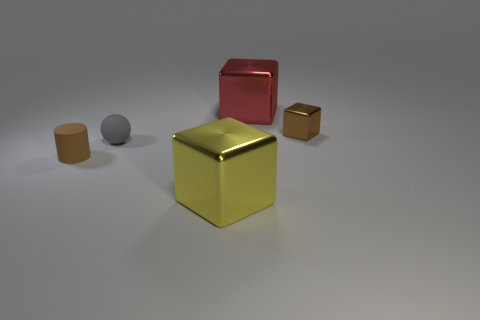What shape is the brown object on the left side of the tiny matte thing that is on the right side of the small cylinder?
Your answer should be compact. Cylinder. What number of other objects are the same material as the ball?
Ensure brevity in your answer.  1. Does the small gray object have the same material as the brown cylinder in front of the small shiny block?
Provide a short and direct response. Yes. How many objects are either large objects in front of the large red shiny cube or small objects left of the red metal object?
Make the answer very short. 3. How many other things are the same color as the rubber sphere?
Your answer should be very brief. 0. Is the number of big yellow metallic things behind the small gray thing greater than the number of big yellow metal blocks that are left of the brown cylinder?
Keep it short and to the point. No. How many cylinders are small matte objects or brown metallic things?
Your answer should be very brief. 1. How many things are either objects that are in front of the red block or spheres?
Keep it short and to the point. 4. There is a big red metal thing on the right side of the big cube in front of the brown object that is in front of the small block; what shape is it?
Provide a succinct answer. Cube. What number of matte objects are the same shape as the small metal thing?
Ensure brevity in your answer.  0. 